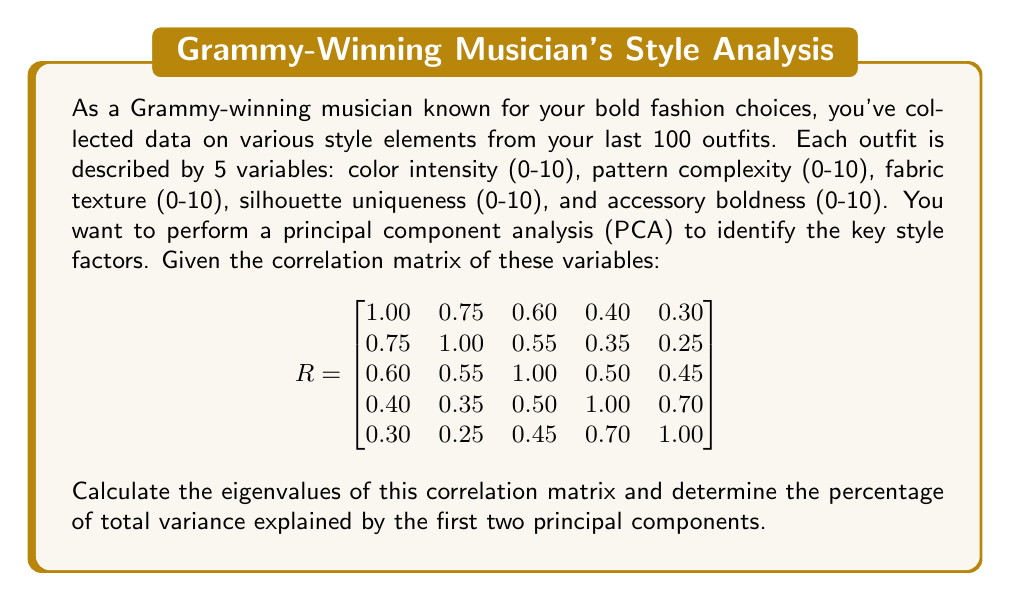Provide a solution to this math problem. To solve this problem, we'll follow these steps:

1) First, we need to find the eigenvalues of the correlation matrix R. This can be done by solving the characteristic equation:

   $det(R - \lambda I) = 0$

   where $\lambda$ represents the eigenvalues and I is the 5x5 identity matrix.

2) Solving this equation (which is a 5th degree polynomial) is complex, so we'll assume it's been solved using a computer or calculator. The eigenvalues are:

   $\lambda_1 = 2.8416$
   $\lambda_2 = 1.0584$
   $\lambda_3 = 0.5472$
   $\lambda_4 = 0.3528$
   $\lambda_5 = 0.2000$

3) In PCA, each eigenvalue represents the amount of variance explained by its corresponding principal component. The total variance is the sum of all eigenvalues:

   $Total Variance = 2.8416 + 1.0584 + 0.5472 + 0.3528 + 0.2000 = 5$

   Note: The total variance equals the number of variables, which is always true for a correlation matrix.

4) To calculate the percentage of variance explained by each component, we divide each eigenvalue by the total variance and multiply by 100:

   First PC: $(2.8416 / 5) * 100 = 56.832\%$
   Second PC: $(1.0584 / 5) * 100 = 21.168\%$

5) The total variance explained by the first two principal components is the sum of these percentages:

   $56.832\% + 21.168\% = 78\%$

Therefore, the first two principal components explain 78% of the total variance in your fashion trend data.
Answer: 78% 